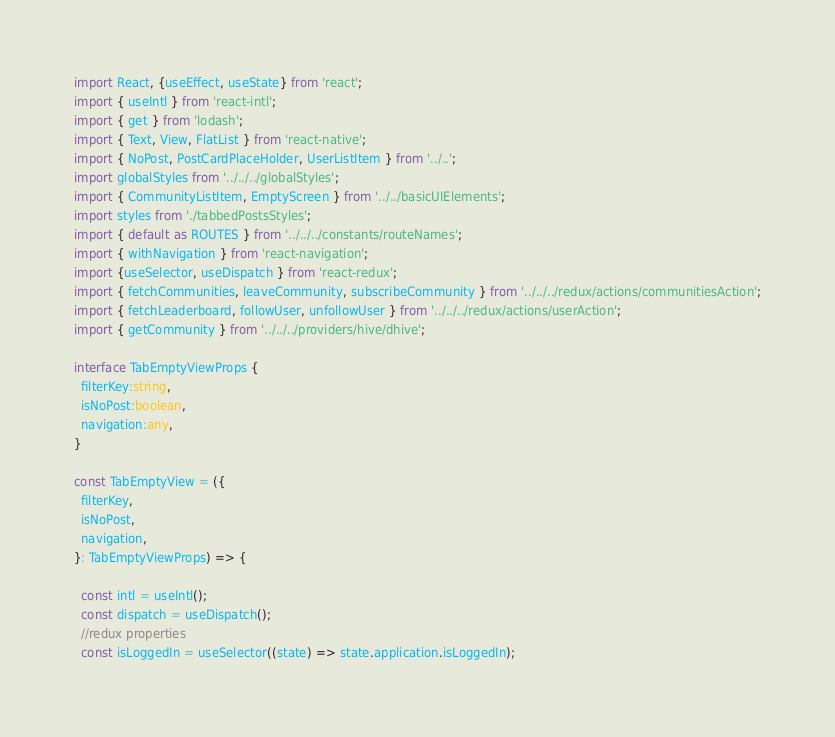<code> <loc_0><loc_0><loc_500><loc_500><_TypeScript_>import React, {useEffect, useState} from 'react';
import { useIntl } from 'react-intl';
import { get } from 'lodash';
import { Text, View, FlatList } from 'react-native';
import { NoPost, PostCardPlaceHolder, UserListItem } from '../..';
import globalStyles from '../../../globalStyles';
import { CommunityListItem, EmptyScreen } from '../../basicUIElements';
import styles from './tabbedPostsStyles';
import { default as ROUTES } from '../../../constants/routeNames';
import { withNavigation } from 'react-navigation';
import {useSelector, useDispatch } from 'react-redux';
import { fetchCommunities, leaveCommunity, subscribeCommunity } from '../../../redux/actions/communitiesAction';
import { fetchLeaderboard, followUser, unfollowUser } from '../../../redux/actions/userAction';
import { getCommunity } from '../../../providers/hive/dhive';

interface TabEmptyViewProps {
  filterKey:string,
  isNoPost:boolean,
  navigation:any,
}

const TabEmptyView = ({
  filterKey,
  isNoPost,
  navigation,
}: TabEmptyViewProps) => {

  const intl = useIntl();
  const dispatch = useDispatch();
  //redux properties
  const isLoggedIn = useSelector((state) => state.application.isLoggedIn);</code> 